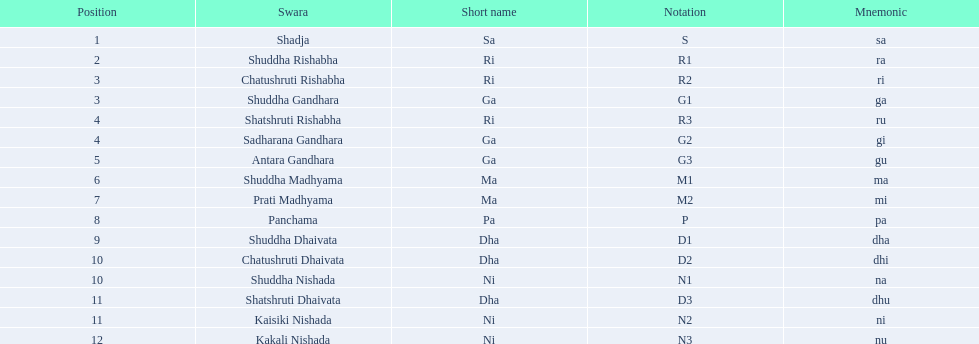Which swara holds the last position? Kakali Nishada. 